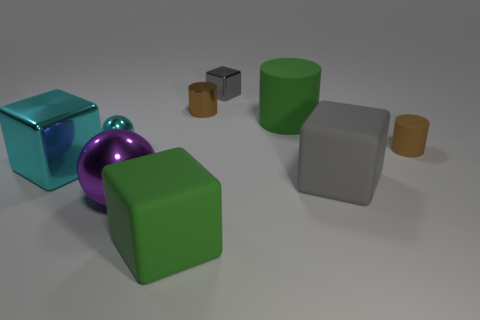Subtract all cyan spheres. How many gray cubes are left? 2 Subtract all large cubes. How many cubes are left? 1 Subtract all green blocks. How many blocks are left? 3 Add 1 tiny red cubes. How many objects exist? 10 Subtract all spheres. How many objects are left? 7 Subtract all cyan cylinders. Subtract all brown blocks. How many cylinders are left? 3 Subtract all gray rubber blocks. Subtract all purple metallic objects. How many objects are left? 7 Add 8 tiny cyan balls. How many tiny cyan balls are left? 9 Add 7 small rubber cylinders. How many small rubber cylinders exist? 8 Subtract 0 red cubes. How many objects are left? 9 